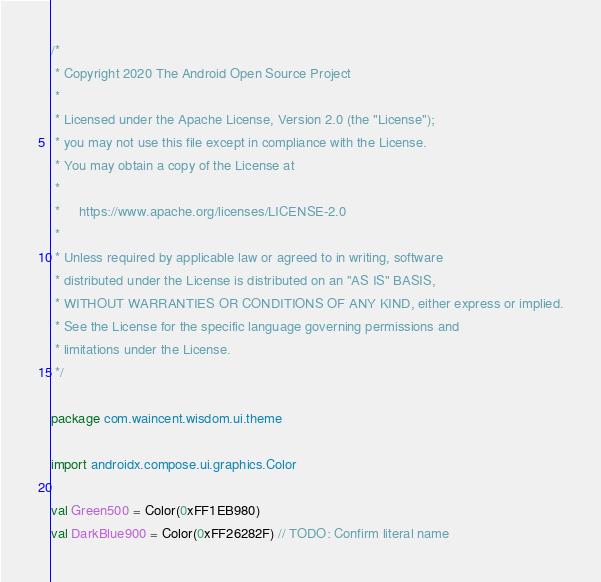Convert code to text. <code><loc_0><loc_0><loc_500><loc_500><_Kotlin_>/*
 * Copyright 2020 The Android Open Source Project
 *
 * Licensed under the Apache License, Version 2.0 (the "License");
 * you may not use this file except in compliance with the License.
 * You may obtain a copy of the License at
 *
 *     https://www.apache.org/licenses/LICENSE-2.0
 *
 * Unless required by applicable law or agreed to in writing, software
 * distributed under the License is distributed on an "AS IS" BASIS,
 * WITHOUT WARRANTIES OR CONDITIONS OF ANY KIND, either express or implied.
 * See the License for the specific language governing permissions and
 * limitations under the License.
 */

package com.waincent.wisdom.ui.theme

import androidx.compose.ui.graphics.Color

val Green500 = Color(0xFF1EB980)
val DarkBlue900 = Color(0xFF26282F) // TODO: Confirm literal name
</code> 